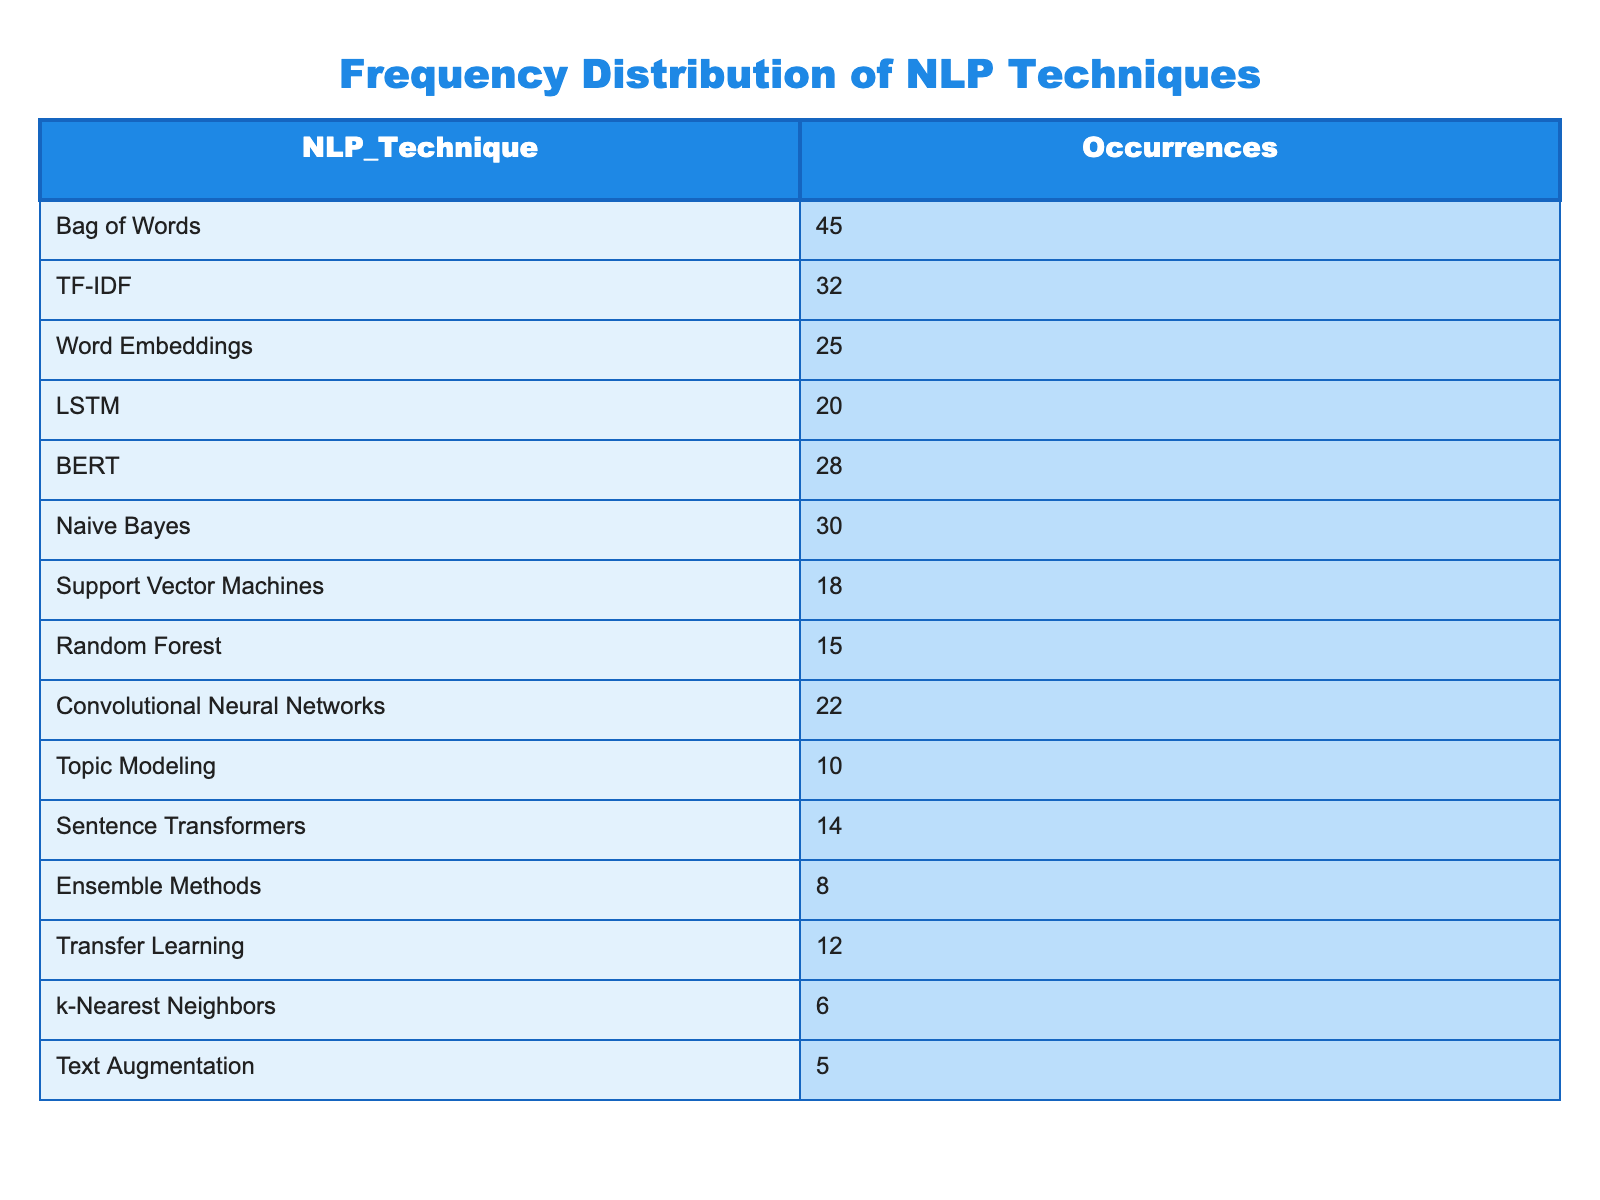What is the highest occurrence of an NLP technique? The table shows that "Bag of Words" has the highest occurrence with a value of 45.
Answer: 45 Which NLP technique has fewer occurrences: LSTM or Convolutional Neural Networks? LSTM has 20 occurrences and Convolutional Neural Networks has 22 occurrences; therefore, LSTM has fewer occurrences.
Answer: LSTM What is the total occurrence of all the NLP techniques listed? To find the total, we sum all the occurrences: 45 + 32 + 25 + 20 + 28 + 30 + 18 + 15 + 22 + 10 + 14 + 8 + 12 + 6 + 5 =  346.
Answer: 346 Is Transfer Learning listed among the NLP techniques? Yes, Transfer Learning is listed, as indicated in the table with 12 occurrences.
Answer: Yes What is the difference in occurrences between TF-IDF and Naive Bayes? TF-IDF has 32 occurrences while Naive Bayes has 30 occurrences. The difference is 32 - 30 = 2.
Answer: 2 What is the average occurrence of the NLP techniques in the table? To calculate the average, we divide the total occurrences (346) by the number of techniques (15): 346 / 15 = 23.07, approximately 23.07.
Answer: 23.07 Which two NLP techniques have occurrences that sum to 50? Looking at combinations, Bag of Words (45) and Text Augmentation (5) add up to 50.
Answer: Bag of Words and Text Augmentation How many NLP techniques have occurrences greater than 20? The techniques with occurrences greater than 20 are: Bag of Words (45), TF-IDF (32), Naive Bayes (30), LSTM (20), BERT (28), Convolutional Neural Networks (22). This totals to six techniques.
Answer: 6 Which NLP technique occurs the least in projects listed? Among all techniques, k-Nearest Neighbors with 6 occurrences is the least.
Answer: k-Nearest Neighbors 